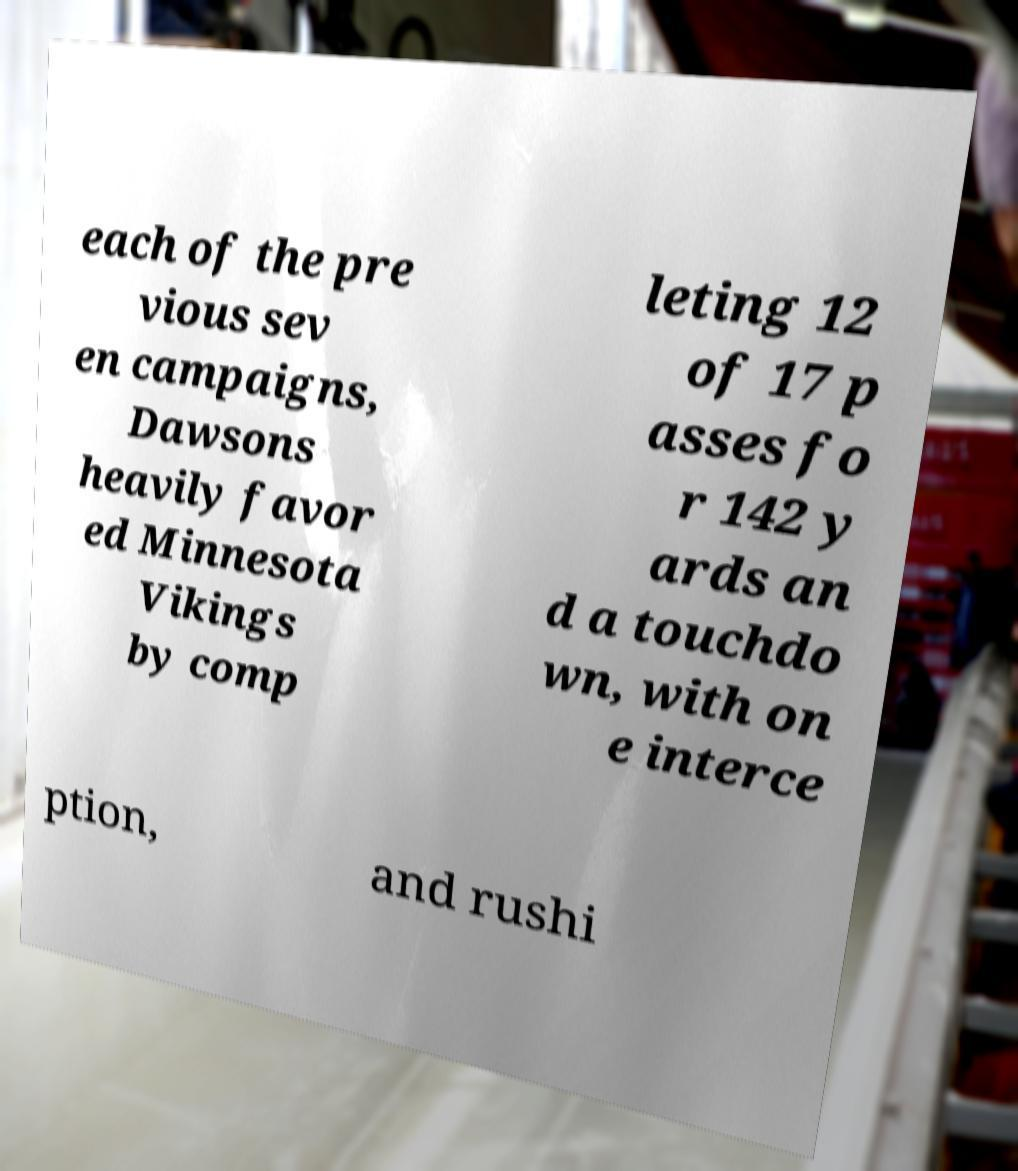Could you assist in decoding the text presented in this image and type it out clearly? each of the pre vious sev en campaigns, Dawsons heavily favor ed Minnesota Vikings by comp leting 12 of 17 p asses fo r 142 y ards an d a touchdo wn, with on e interce ption, and rushi 